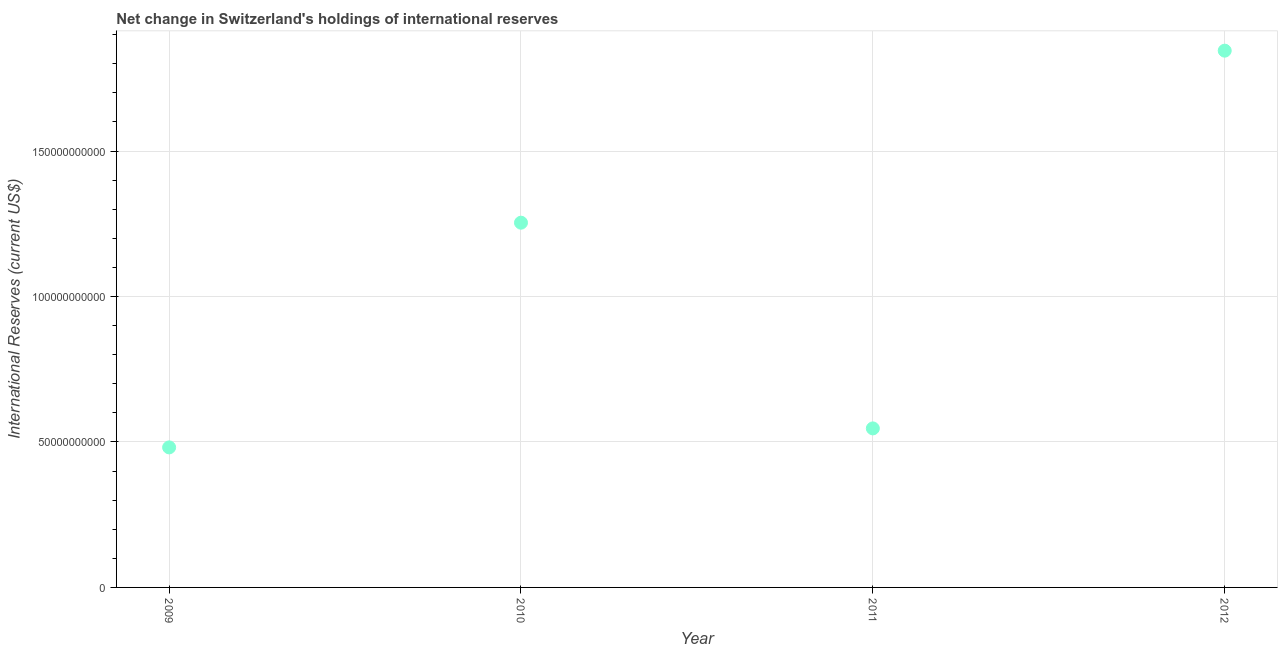What is the reserves and related items in 2010?
Keep it short and to the point. 1.25e+11. Across all years, what is the maximum reserves and related items?
Your response must be concise. 1.85e+11. Across all years, what is the minimum reserves and related items?
Keep it short and to the point. 4.81e+1. In which year was the reserves and related items maximum?
Your response must be concise. 2012. In which year was the reserves and related items minimum?
Make the answer very short. 2009. What is the sum of the reserves and related items?
Give a very brief answer. 4.13e+11. What is the difference between the reserves and related items in 2010 and 2011?
Offer a terse response. 7.07e+1. What is the average reserves and related items per year?
Your answer should be compact. 1.03e+11. What is the median reserves and related items?
Provide a short and direct response. 9.00e+1. What is the ratio of the reserves and related items in 2009 to that in 2012?
Provide a succinct answer. 0.26. Is the reserves and related items in 2010 less than that in 2011?
Provide a short and direct response. No. What is the difference between the highest and the second highest reserves and related items?
Your response must be concise. 5.91e+1. Is the sum of the reserves and related items in 2009 and 2011 greater than the maximum reserves and related items across all years?
Ensure brevity in your answer.  No. What is the difference between the highest and the lowest reserves and related items?
Provide a succinct answer. 1.36e+11. In how many years, is the reserves and related items greater than the average reserves and related items taken over all years?
Ensure brevity in your answer.  2. Does the reserves and related items monotonically increase over the years?
Offer a very short reply. No. How many years are there in the graph?
Your answer should be very brief. 4. What is the difference between two consecutive major ticks on the Y-axis?
Offer a very short reply. 5.00e+1. Are the values on the major ticks of Y-axis written in scientific E-notation?
Offer a terse response. No. Does the graph contain any zero values?
Make the answer very short. No. Does the graph contain grids?
Offer a very short reply. Yes. What is the title of the graph?
Provide a short and direct response. Net change in Switzerland's holdings of international reserves. What is the label or title of the X-axis?
Your answer should be very brief. Year. What is the label or title of the Y-axis?
Provide a short and direct response. International Reserves (current US$). What is the International Reserves (current US$) in 2009?
Make the answer very short. 4.81e+1. What is the International Reserves (current US$) in 2010?
Offer a very short reply. 1.25e+11. What is the International Reserves (current US$) in 2011?
Your answer should be very brief. 5.47e+1. What is the International Reserves (current US$) in 2012?
Provide a succinct answer. 1.85e+11. What is the difference between the International Reserves (current US$) in 2009 and 2010?
Keep it short and to the point. -7.72e+1. What is the difference between the International Reserves (current US$) in 2009 and 2011?
Provide a short and direct response. -6.53e+09. What is the difference between the International Reserves (current US$) in 2009 and 2012?
Provide a succinct answer. -1.36e+11. What is the difference between the International Reserves (current US$) in 2010 and 2011?
Give a very brief answer. 7.07e+1. What is the difference between the International Reserves (current US$) in 2010 and 2012?
Give a very brief answer. -5.91e+1. What is the difference between the International Reserves (current US$) in 2011 and 2012?
Make the answer very short. -1.30e+11. What is the ratio of the International Reserves (current US$) in 2009 to that in 2010?
Your response must be concise. 0.38. What is the ratio of the International Reserves (current US$) in 2009 to that in 2011?
Provide a short and direct response. 0.88. What is the ratio of the International Reserves (current US$) in 2009 to that in 2012?
Provide a short and direct response. 0.26. What is the ratio of the International Reserves (current US$) in 2010 to that in 2011?
Make the answer very short. 2.29. What is the ratio of the International Reserves (current US$) in 2010 to that in 2012?
Your response must be concise. 0.68. What is the ratio of the International Reserves (current US$) in 2011 to that in 2012?
Give a very brief answer. 0.3. 